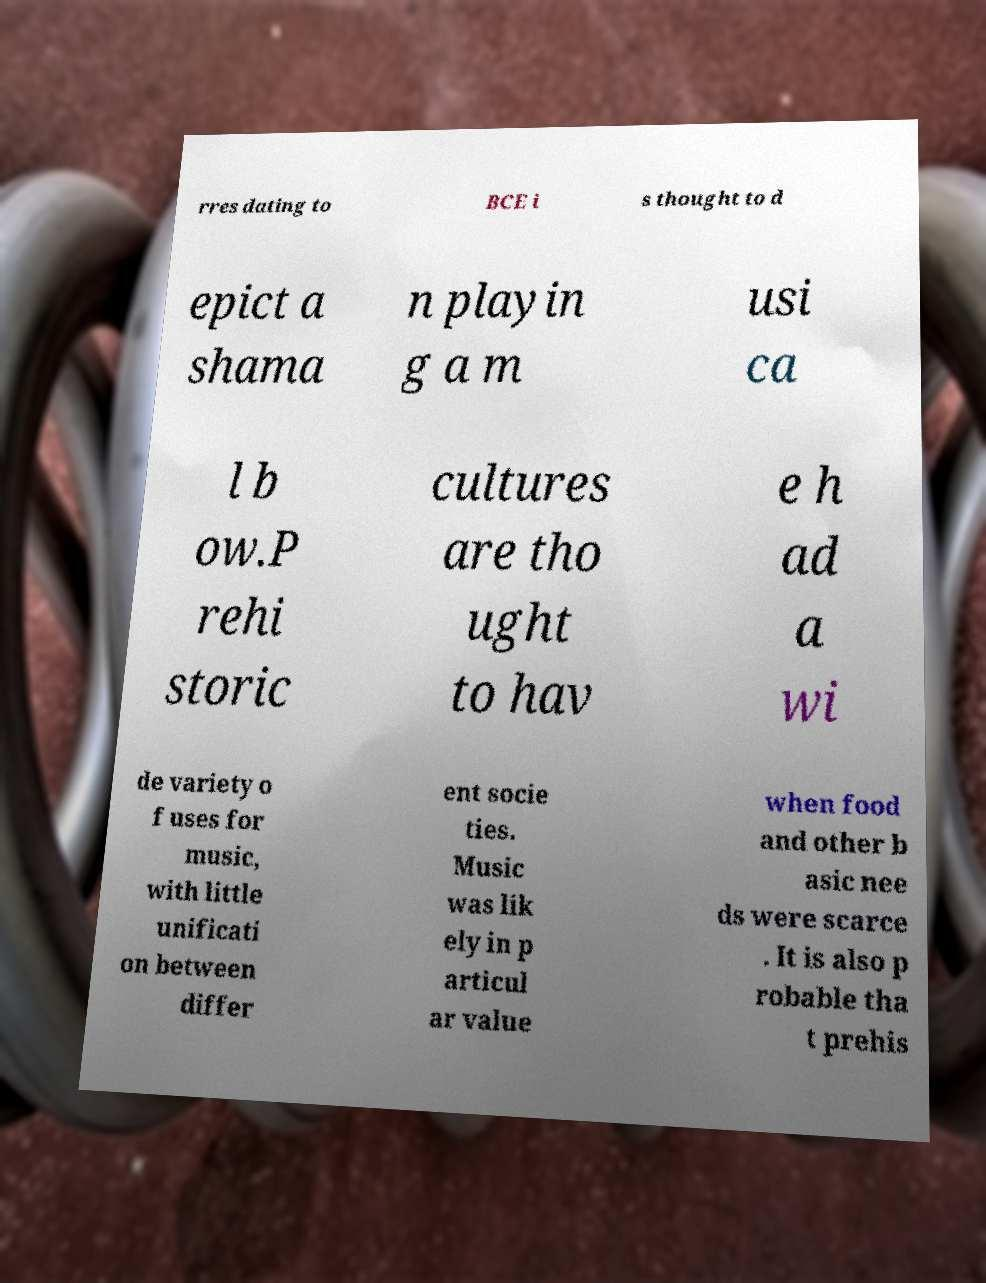I need the written content from this picture converted into text. Can you do that? rres dating to BCE i s thought to d epict a shama n playin g a m usi ca l b ow.P rehi storic cultures are tho ught to hav e h ad a wi de variety o f uses for music, with little unificati on between differ ent socie ties. Music was lik ely in p articul ar value when food and other b asic nee ds were scarce . It is also p robable tha t prehis 